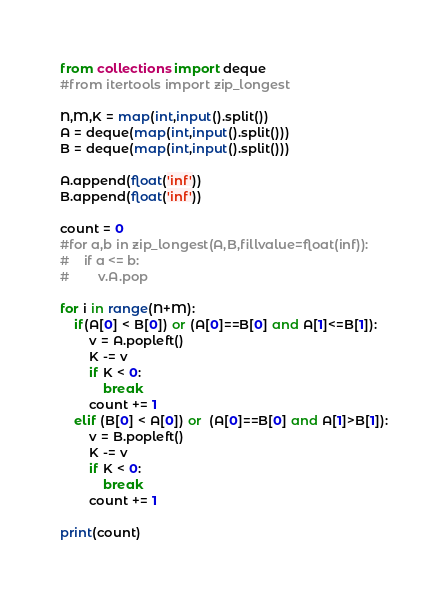Convert code to text. <code><loc_0><loc_0><loc_500><loc_500><_Python_>from collections import deque
#from itertools import zip_longest

N,M,K = map(int,input().split())
A = deque(map(int,input().split()))
B = deque(map(int,input().split()))

A.append(float('inf'))
B.append(float('inf'))

count = 0
#for a,b in zip_longest(A,B,fillvalue=float(inf)):
#    if a <= b:
#        v.A.pop 

for i in range(N+M):
    if(A[0] < B[0]) or (A[0]==B[0] and A[1]<=B[1]):
        v = A.popleft()
        K -= v
        if K < 0:
            break
        count += 1
    elif (B[0] < A[0]) or  (A[0]==B[0] and A[1]>B[1]):
        v = B.popleft()
        K -= v
        if K < 0:
            break
        count += 1

print(count)
</code> 